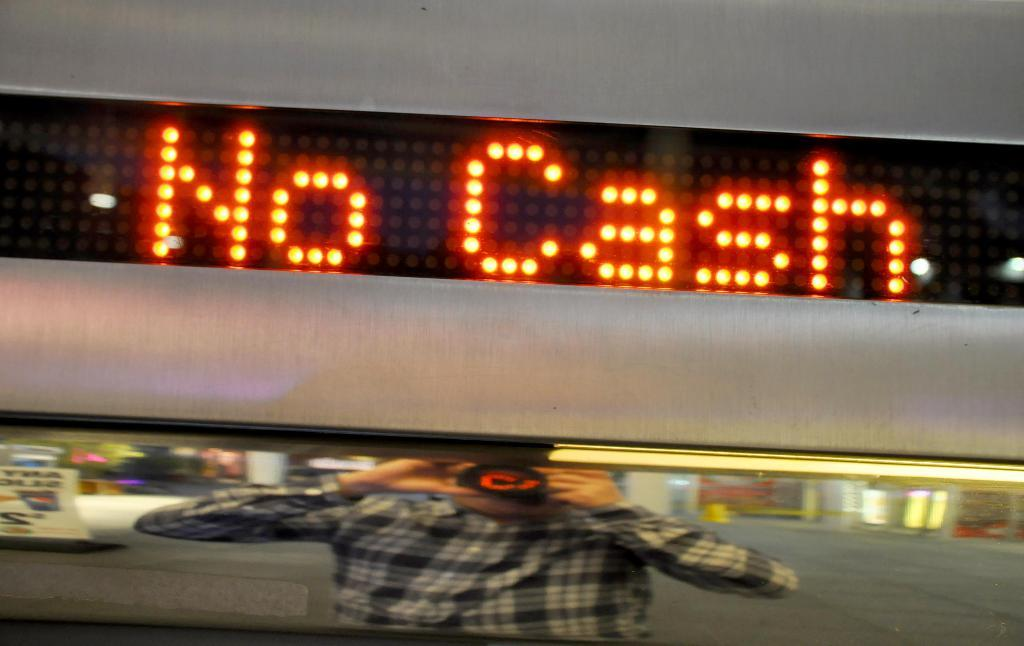<image>
Offer a succinct explanation of the picture presented. A person is reflected in a mirror as they take a picture with a sign showing No Cash above it. 